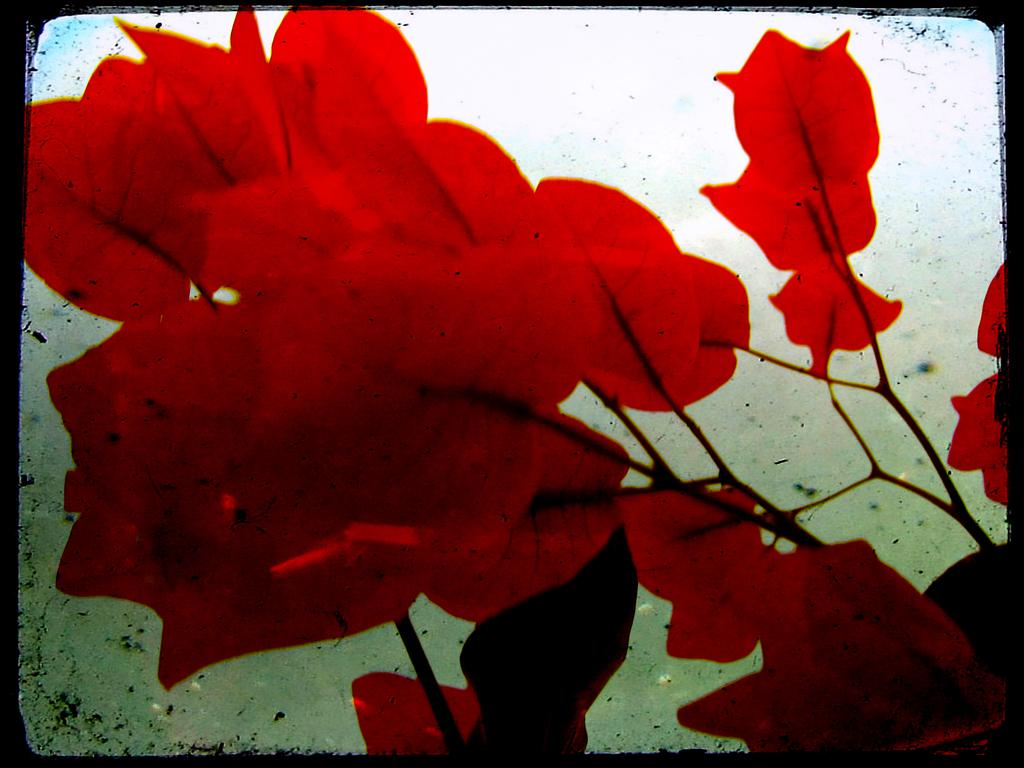What is the main subject in the center of the image? There are red color petals in the center of the image. What type of army is present in the image? There is no army present in the image; it features red color petals in the center. What type of station is depicted in the image? There is no station depicted in the image; it features red color petals in the center. 